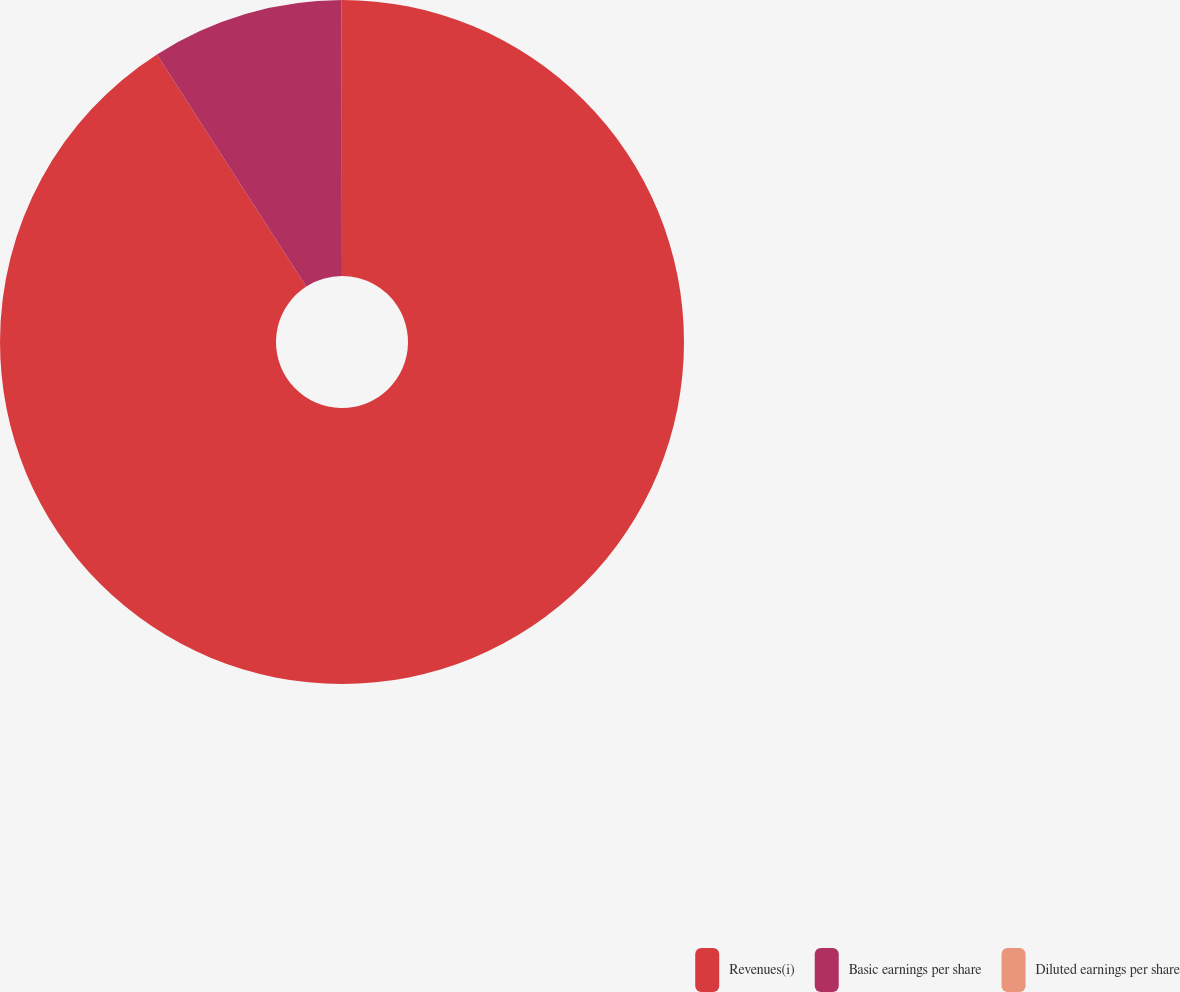<chart> <loc_0><loc_0><loc_500><loc_500><pie_chart><fcel>Revenues(i)<fcel>Basic earnings per share<fcel>Diluted earnings per share<nl><fcel>90.9%<fcel>9.09%<fcel>0.01%<nl></chart> 